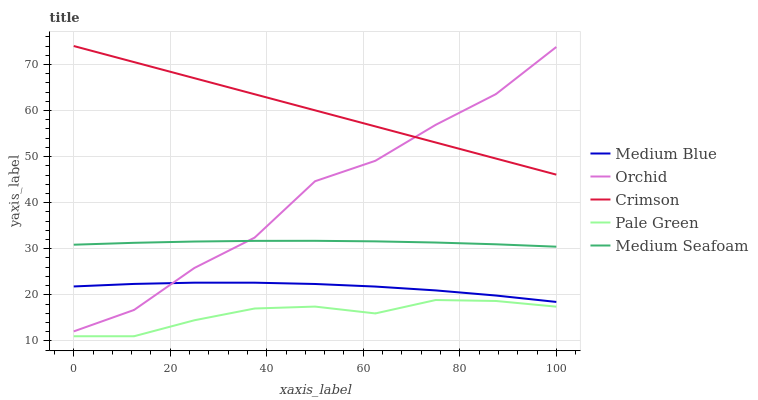Does Pale Green have the minimum area under the curve?
Answer yes or no. Yes. Does Crimson have the maximum area under the curve?
Answer yes or no. Yes. Does Medium Blue have the minimum area under the curve?
Answer yes or no. No. Does Medium Blue have the maximum area under the curve?
Answer yes or no. No. Is Crimson the smoothest?
Answer yes or no. Yes. Is Orchid the roughest?
Answer yes or no. Yes. Is Pale Green the smoothest?
Answer yes or no. No. Is Pale Green the roughest?
Answer yes or no. No. Does Pale Green have the lowest value?
Answer yes or no. Yes. Does Medium Blue have the lowest value?
Answer yes or no. No. Does Crimson have the highest value?
Answer yes or no. Yes. Does Medium Blue have the highest value?
Answer yes or no. No. Is Pale Green less than Crimson?
Answer yes or no. Yes. Is Medium Seafoam greater than Pale Green?
Answer yes or no. Yes. Does Orchid intersect Medium Seafoam?
Answer yes or no. Yes. Is Orchid less than Medium Seafoam?
Answer yes or no. No. Is Orchid greater than Medium Seafoam?
Answer yes or no. No. Does Pale Green intersect Crimson?
Answer yes or no. No. 